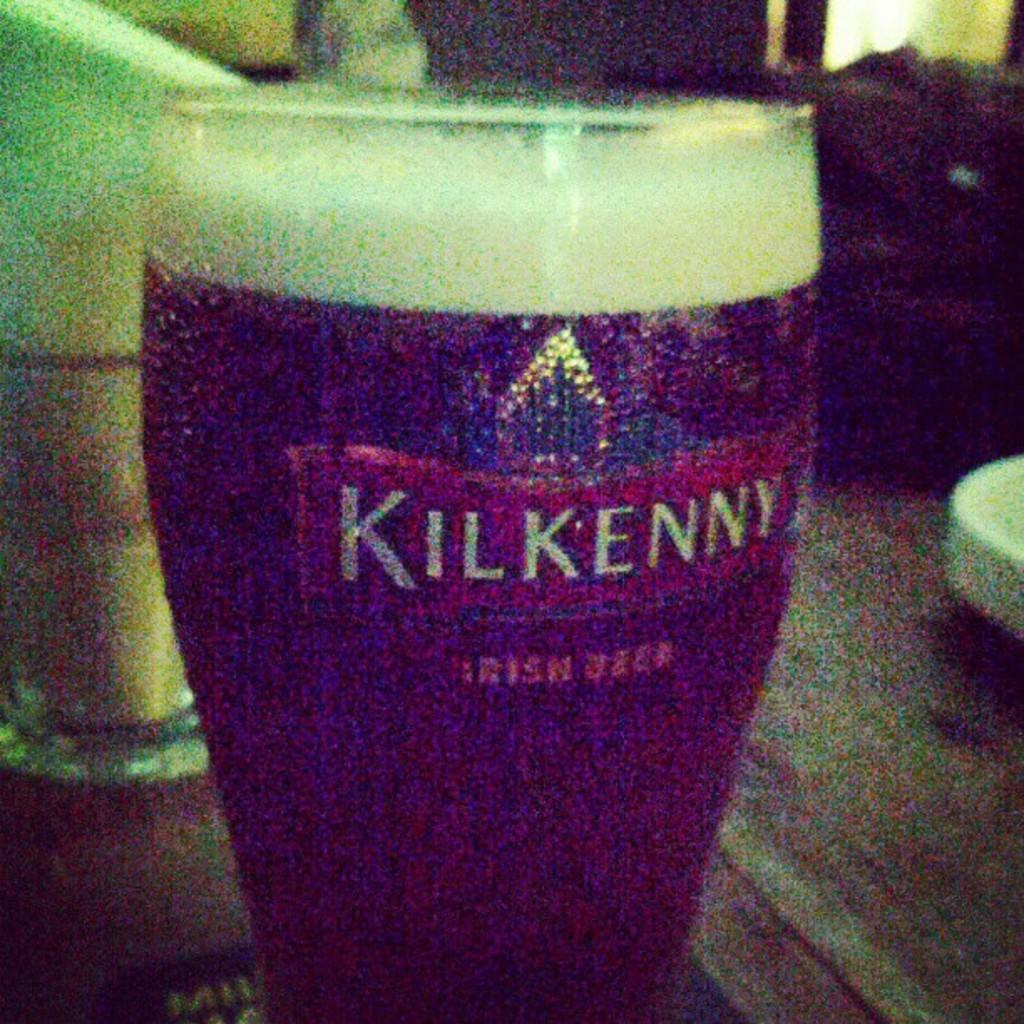<image>
Render a clear and concise summary of the photo. a glass saying Kilkenny on the side and beer in it 